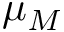<formula> <loc_0><loc_0><loc_500><loc_500>\mu _ { M }</formula> 